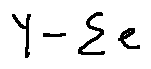Convert formula to latex. <formula><loc_0><loc_0><loc_500><loc_500>Y - \sum e</formula> 